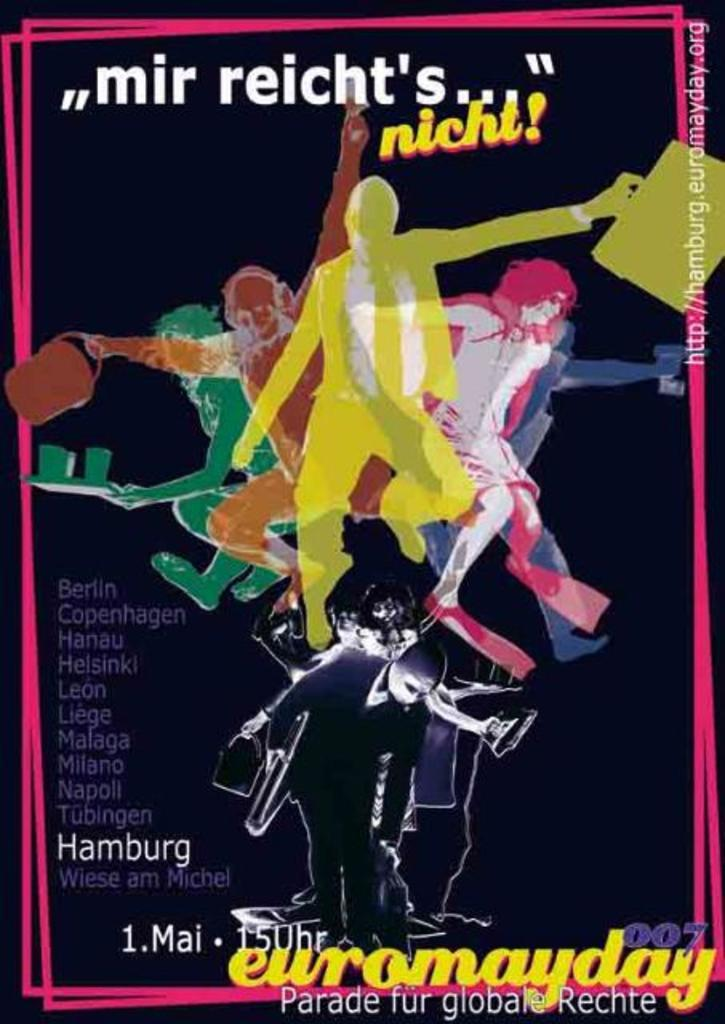<image>
Share a concise interpretation of the image provided. An event takes place in locations such as Berlin, Copenhagen, Hanau, and Helsinki, among others. 